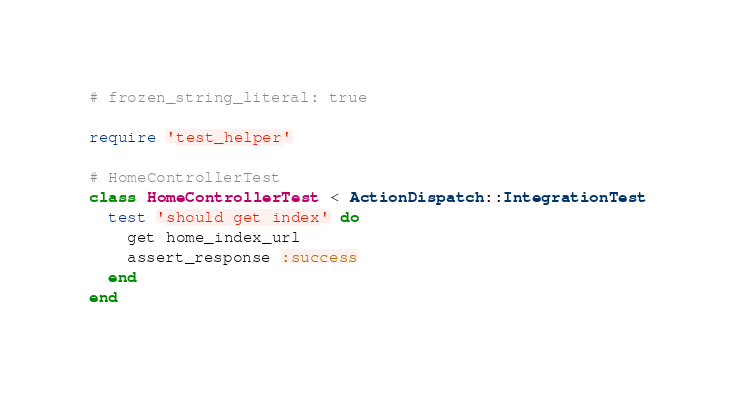<code> <loc_0><loc_0><loc_500><loc_500><_Ruby_># frozen_string_literal: true

require 'test_helper'

# HomeControllerTest
class HomeControllerTest < ActionDispatch::IntegrationTest
  test 'should get index' do
    get home_index_url
    assert_response :success
  end
end
</code> 